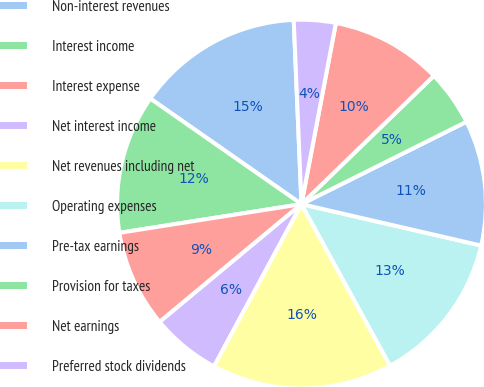Convert chart to OTSL. <chart><loc_0><loc_0><loc_500><loc_500><pie_chart><fcel>Non-interest revenues<fcel>Interest income<fcel>Interest expense<fcel>Net interest income<fcel>Net revenues including net<fcel>Operating expenses<fcel>Pre-tax earnings<fcel>Provision for taxes<fcel>Net earnings<fcel>Preferred stock dividends<nl><fcel>14.63%<fcel>12.19%<fcel>8.54%<fcel>6.1%<fcel>15.85%<fcel>13.41%<fcel>10.98%<fcel>4.88%<fcel>9.76%<fcel>3.66%<nl></chart> 